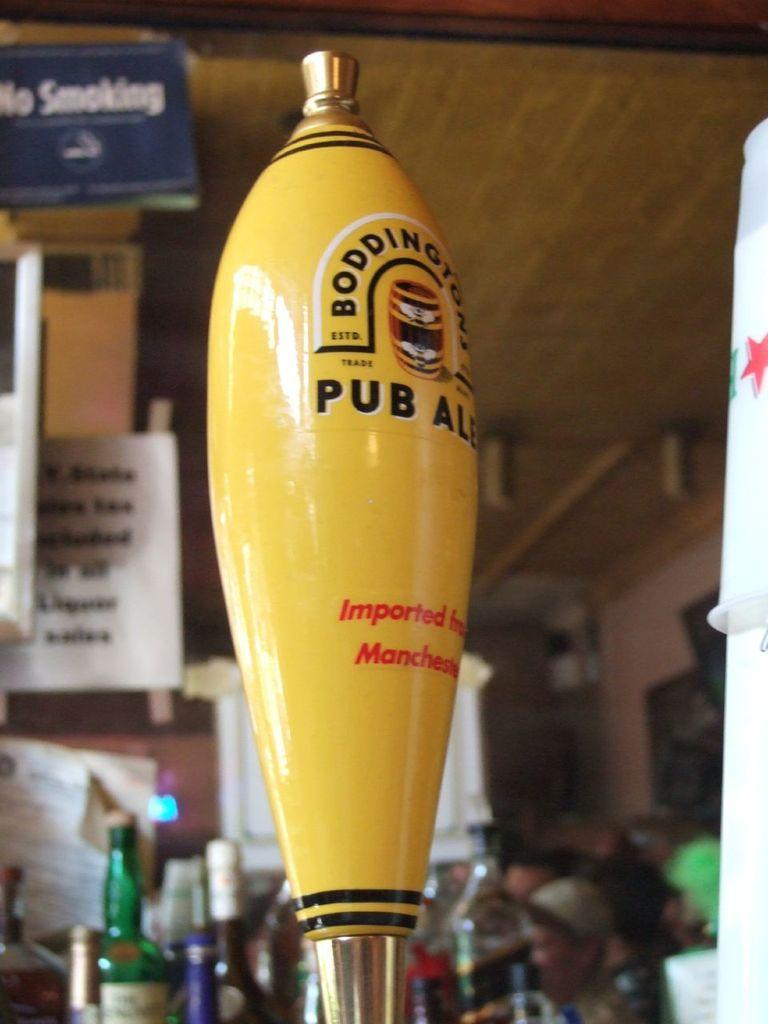<image>
Create a compact narrative representing the image presented. Yes, Bondingtons Pub Ale is on tap, but there is no smoking allowed. 